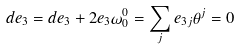Convert formula to latex. <formula><loc_0><loc_0><loc_500><loc_500>d e _ { 3 } = d e _ { 3 } + 2 e _ { 3 } \omega ^ { 0 } _ { 0 } = \sum _ { j } e _ { 3 j } \theta ^ { j } = 0</formula> 